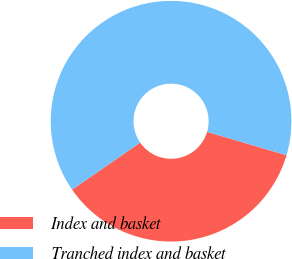Convert chart to OTSL. <chart><loc_0><loc_0><loc_500><loc_500><pie_chart><fcel>Index and basket<fcel>Tranched index and basket<nl><fcel>35.82%<fcel>64.18%<nl></chart> 